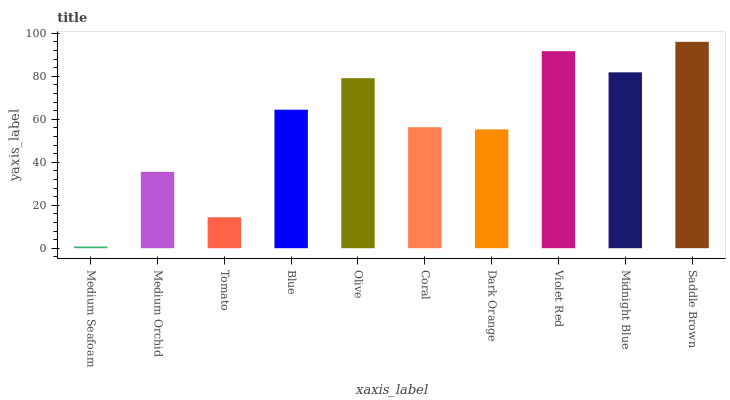Is Medium Orchid the minimum?
Answer yes or no. No. Is Medium Orchid the maximum?
Answer yes or no. No. Is Medium Orchid greater than Medium Seafoam?
Answer yes or no. Yes. Is Medium Seafoam less than Medium Orchid?
Answer yes or no. Yes. Is Medium Seafoam greater than Medium Orchid?
Answer yes or no. No. Is Medium Orchid less than Medium Seafoam?
Answer yes or no. No. Is Blue the high median?
Answer yes or no. Yes. Is Coral the low median?
Answer yes or no. Yes. Is Olive the high median?
Answer yes or no. No. Is Blue the low median?
Answer yes or no. No. 